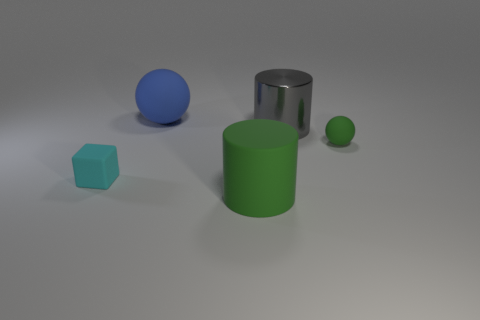What number of other things are there of the same color as the small sphere?
Ensure brevity in your answer.  1. The tiny object right of the tiny rubber object that is left of the object that is in front of the small cyan rubber block is what shape?
Keep it short and to the point. Sphere. Are there more tiny cubes right of the big rubber cylinder than large metallic objects?
Give a very brief answer. No. Are there any other gray metal objects of the same shape as the metal object?
Your response must be concise. No. Are the gray cylinder and the big cylinder in front of the cyan block made of the same material?
Ensure brevity in your answer.  No. What is the color of the small cube?
Your response must be concise. Cyan. There is a tiny thing on the left side of the ball that is on the left side of the small green rubber object; what number of rubber cylinders are in front of it?
Provide a succinct answer. 1. There is a cyan matte object; are there any tiny cyan blocks right of it?
Give a very brief answer. No. How many other large objects are the same material as the cyan thing?
Make the answer very short. 2. What number of objects are either tiny green matte balls or blue cylinders?
Your answer should be very brief. 1. 